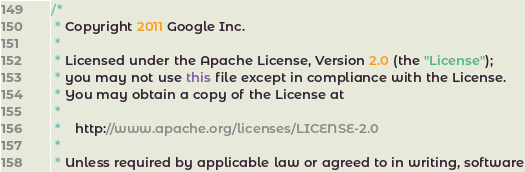<code> <loc_0><loc_0><loc_500><loc_500><_Java_>/*
 * Copyright 2011 Google Inc.
 *
 * Licensed under the Apache License, Version 2.0 (the "License");
 * you may not use this file except in compliance with the License.
 * You may obtain a copy of the License at
 *
 *    http://www.apache.org/licenses/LICENSE-2.0
 *
 * Unless required by applicable law or agreed to in writing, software</code> 